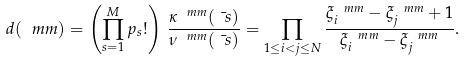Convert formula to latex. <formula><loc_0><loc_0><loc_500><loc_500>d ( \ m m ) = \left ( \prod _ { s = 1 } ^ { M } p _ { s } ! \right ) \, \frac { \kappa ^ { \ m m } ( \bar { \ s } ) } { \nu ^ { \ m m } ( \bar { \ s } ) } = \prod _ { 1 \leq i < j \leq N } \frac { \xi ^ { \ m m } _ { i } - \xi ^ { \ m m } _ { j } + 1 } { \xi ^ { \ m m } _ { i } - \xi ^ { \ m m } _ { j } } .</formula> 